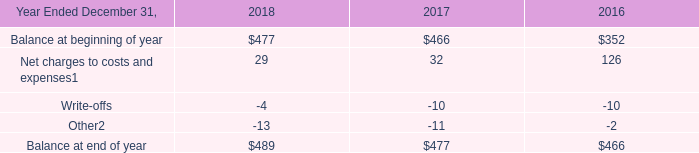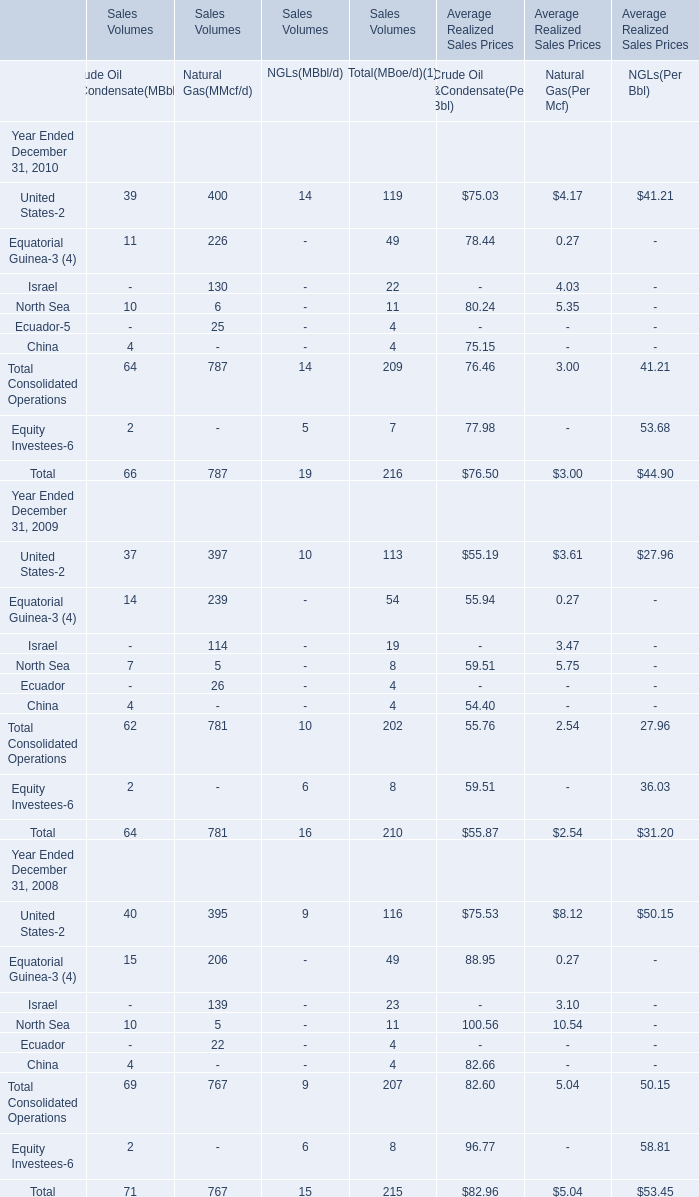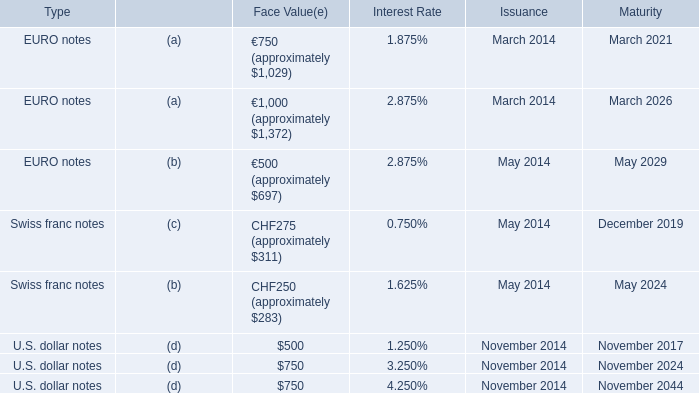What is the sum of Israel of Natural Gas(MMcf/d) in 2010 and Write-offs in 2017? 
Computations: (130 - 10)
Answer: 120.0. 